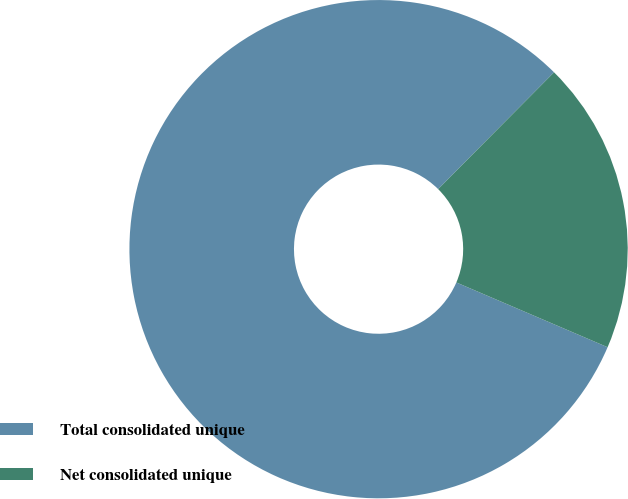Convert chart. <chart><loc_0><loc_0><loc_500><loc_500><pie_chart><fcel>Total consolidated unique<fcel>Net consolidated unique<nl><fcel>81.0%<fcel>19.0%<nl></chart> 